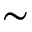<formula> <loc_0><loc_0><loc_500><loc_500>\sim</formula> 